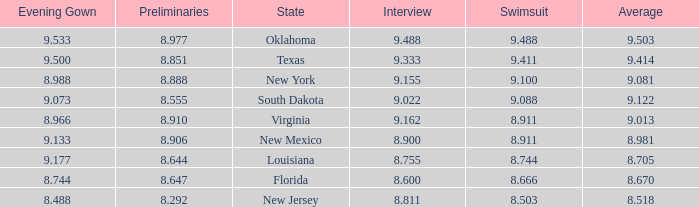What is the total number of average where evening gown is 8.988 1.0. Write the full table. {'header': ['Evening Gown', 'Preliminaries', 'State', 'Interview', 'Swimsuit', 'Average'], 'rows': [['9.533', '8.977', 'Oklahoma', '9.488', '9.488', '9.503'], ['9.500', '8.851', 'Texas', '9.333', '9.411', '9.414'], ['8.988', '8.888', 'New York', '9.155', '9.100', '9.081'], ['9.073', '8.555', 'South Dakota', '9.022', '9.088', '9.122'], ['8.966', '8.910', 'Virginia', '9.162', '8.911', '9.013'], ['9.133', '8.906', 'New Mexico', '8.900', '8.911', '8.981'], ['9.177', '8.644', 'Louisiana', '8.755', '8.744', '8.705'], ['8.744', '8.647', 'Florida', '8.600', '8.666', '8.670'], ['8.488', '8.292', 'New Jersey', '8.811', '8.503', '8.518']]} 